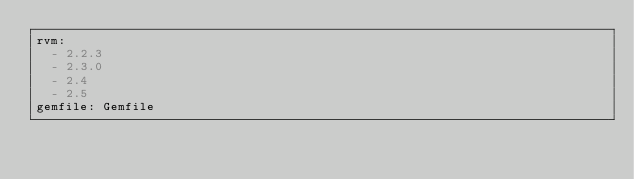<code> <loc_0><loc_0><loc_500><loc_500><_YAML_>rvm:
  - 2.2.3
  - 2.3.0
  - 2.4
  - 2.5
gemfile: Gemfile
</code> 